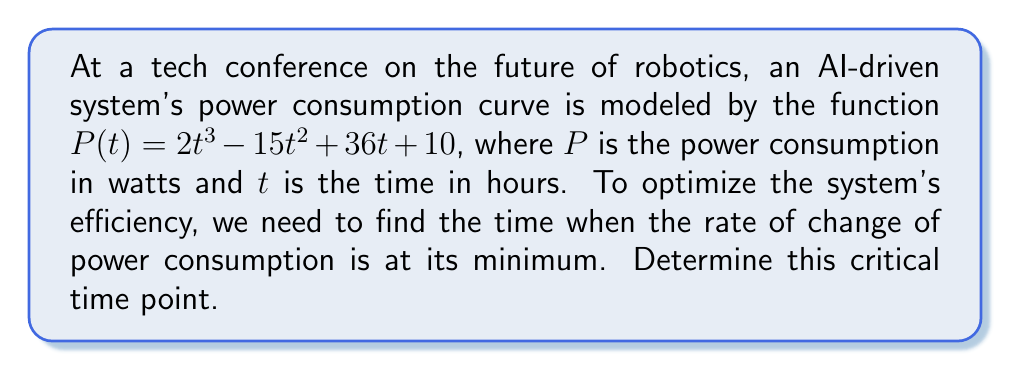Show me your answer to this math problem. To find the time when the rate of change of power consumption is at its minimum, we need to follow these steps:

1) First, we need to find the rate of change of power consumption. This is the first derivative of $P(t)$:
   $$P'(t) = 6t^2 - 30t + 36$$

2) To find the minimum rate of change, we need to find where the second derivative equals zero. Let's calculate the second derivative:
   $$P''(t) = 12t - 30$$

3) Set the second derivative equal to zero and solve for $t$:
   $$12t - 30 = 0$$
   $$12t = 30$$
   $$t = \frac{30}{12} = \frac{5}{2} = 2.5$$

4) To confirm this is a minimum (not a maximum), we can check the sign of the third derivative:
   $$P'''(t) = 12$$
   Since this is positive, we confirm that $t = 2.5$ gives a minimum rate of change.

Therefore, the rate of change of power consumption is at its minimum when $t = 2.5$ hours.
Answer: 2.5 hours 